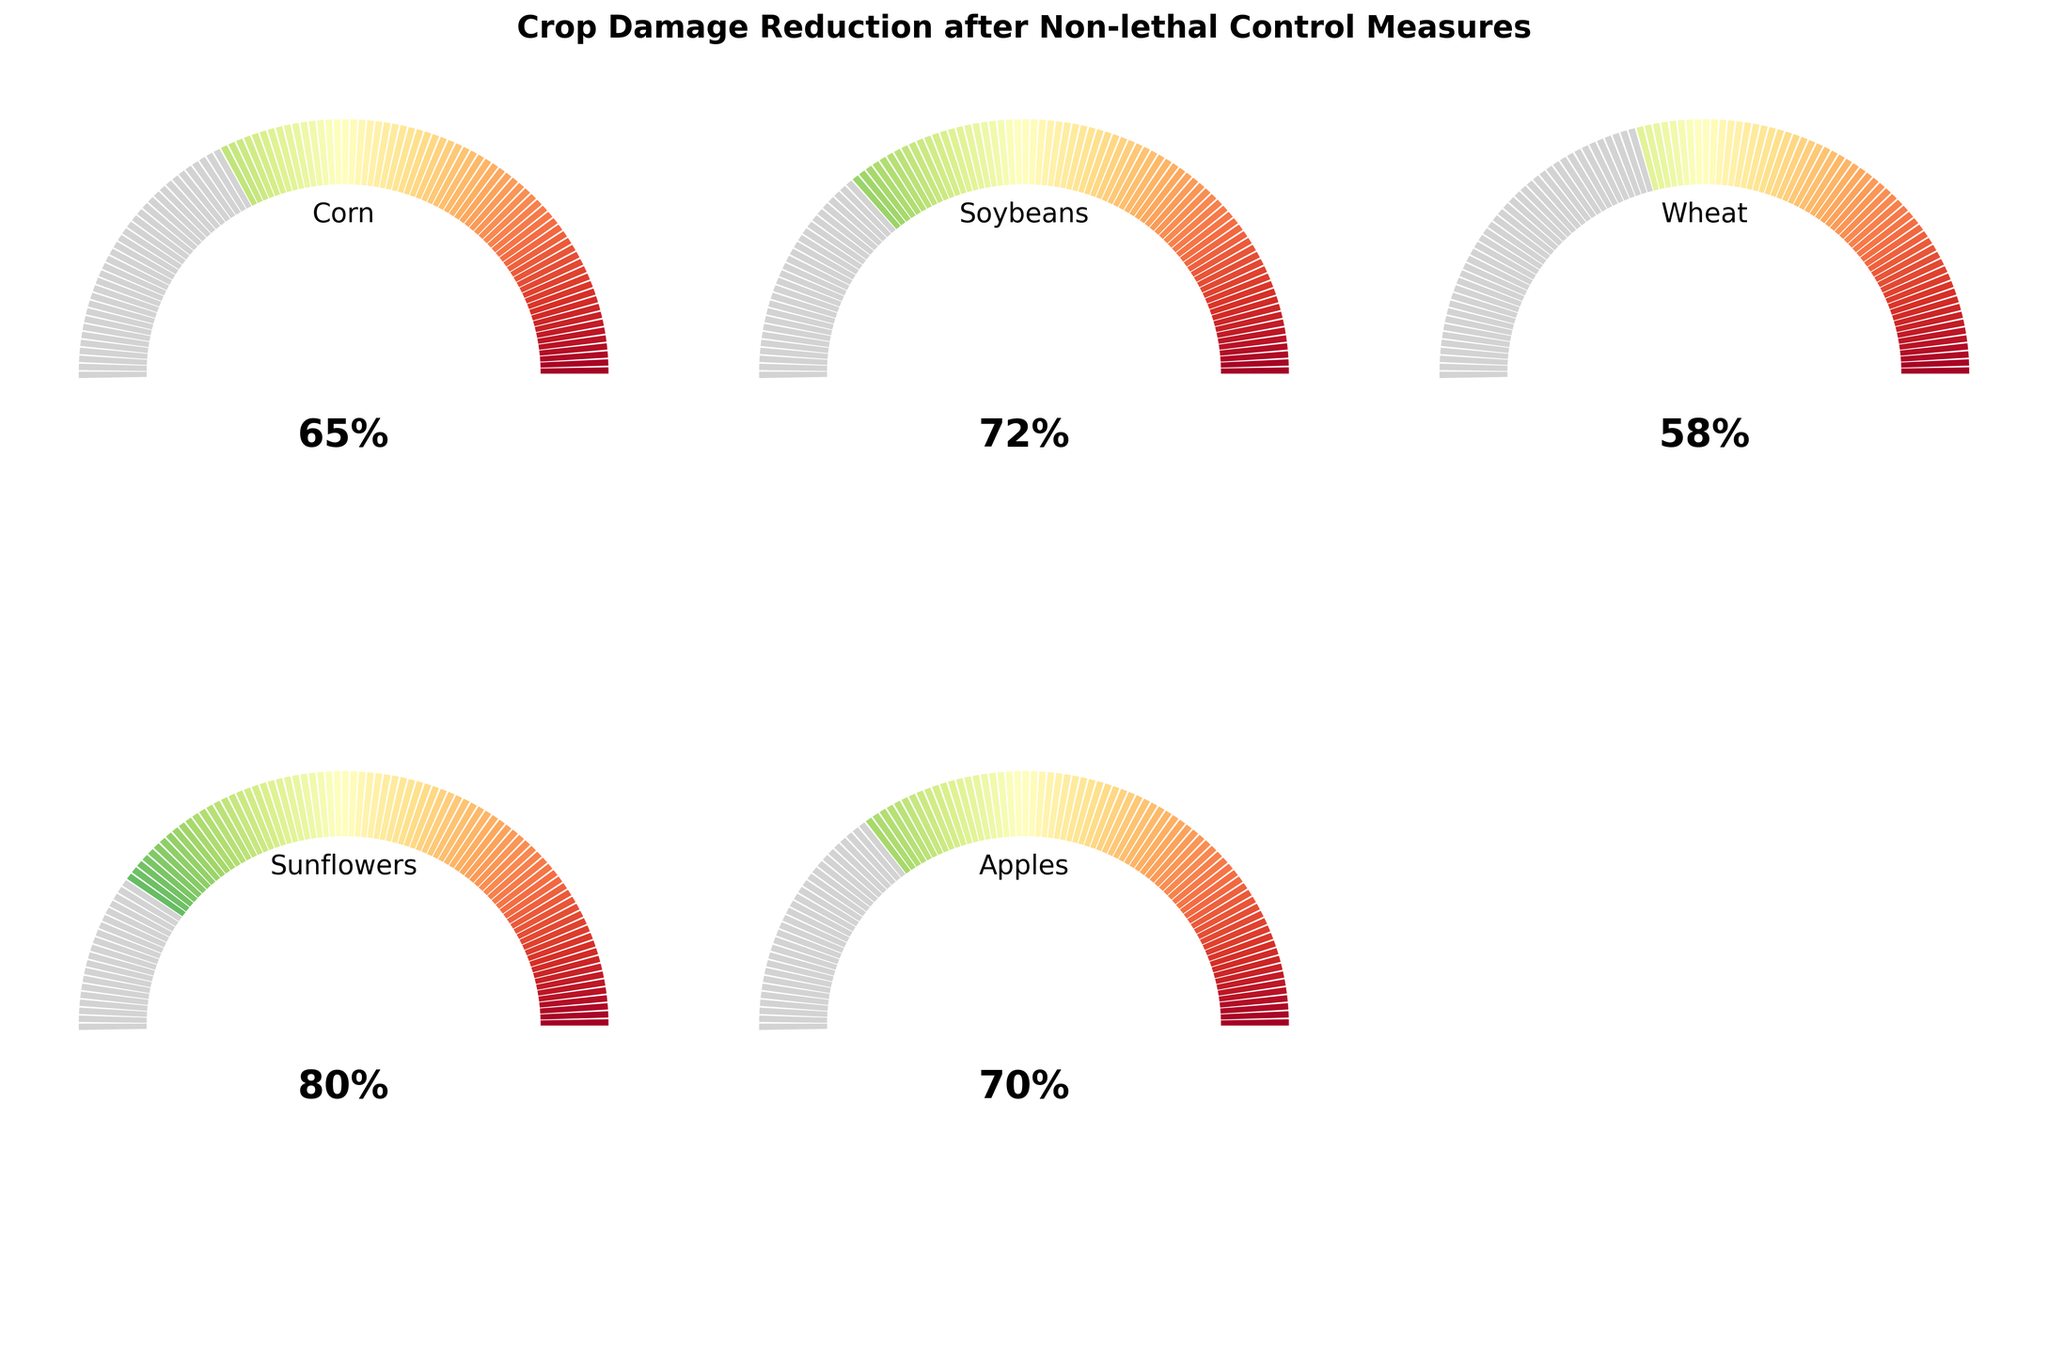Which crop shows the highest reduction in crop damage? Based on the gauges, Sunflowers have the highest reduction in crop damage with an 80% reduction.
Answer: Sunflowers What is the overall title of the figure? The title is displayed at the top of the figure. It reads "Crop Damage Reduction after Non-lethal Control Measures".
Answer: Crop Damage Reduction after Non-lethal Control Measures Which crop has the lowest percentage reduction in crop damage? According to the gauges, Wheat has the lowest reduction at 58%.
Answer: Wheat What is the average percentage reduction across all the crops? Sum all the percentages: (65+72+58+80+70) = 345. Divide by the number of crops (5), so 345/5 = 69.
Answer: 69 How many crops have more than 70% reduction in crop damage? The crops with more than 70% reduction are Soybeans (72%), Sunflowers (80%), and Apples (70%). Therefore, the count is 3 (Note: Apples exactly at 70% is counted as greater than or equal to 70%).
Answer: 3 Which crop is listed in the middle gauge? The middle gauge is the third one, which represents Wheat.
Answer: Wheat What is the difference in damage reduction between Corn and Soybeans? Corn has a reduction of 65%, and Soybeans have a reduction of 72%. The difference is 72% - 65% = 7%.
Answer: 7% How is the percentage represented visually in the gauge? The gauge represents percentages with half-circles where each degree corresponds to 1.8%. A color gradient shows the progress up to the specified percentage.
Answer: Half-circles with a color gradient By how much does Sunflowers' damage reduction exceed Wheat's? Sunflowers have an 80% reduction, while Wheat has a 58% reduction. The difference is 80% - 58% = 22%.
Answer: 22% Is the percentage reduction in Apple damage higher than Corn? Yes, Apples have a 70% reduction, while Corn has a 65% reduction.
Answer: Yes 